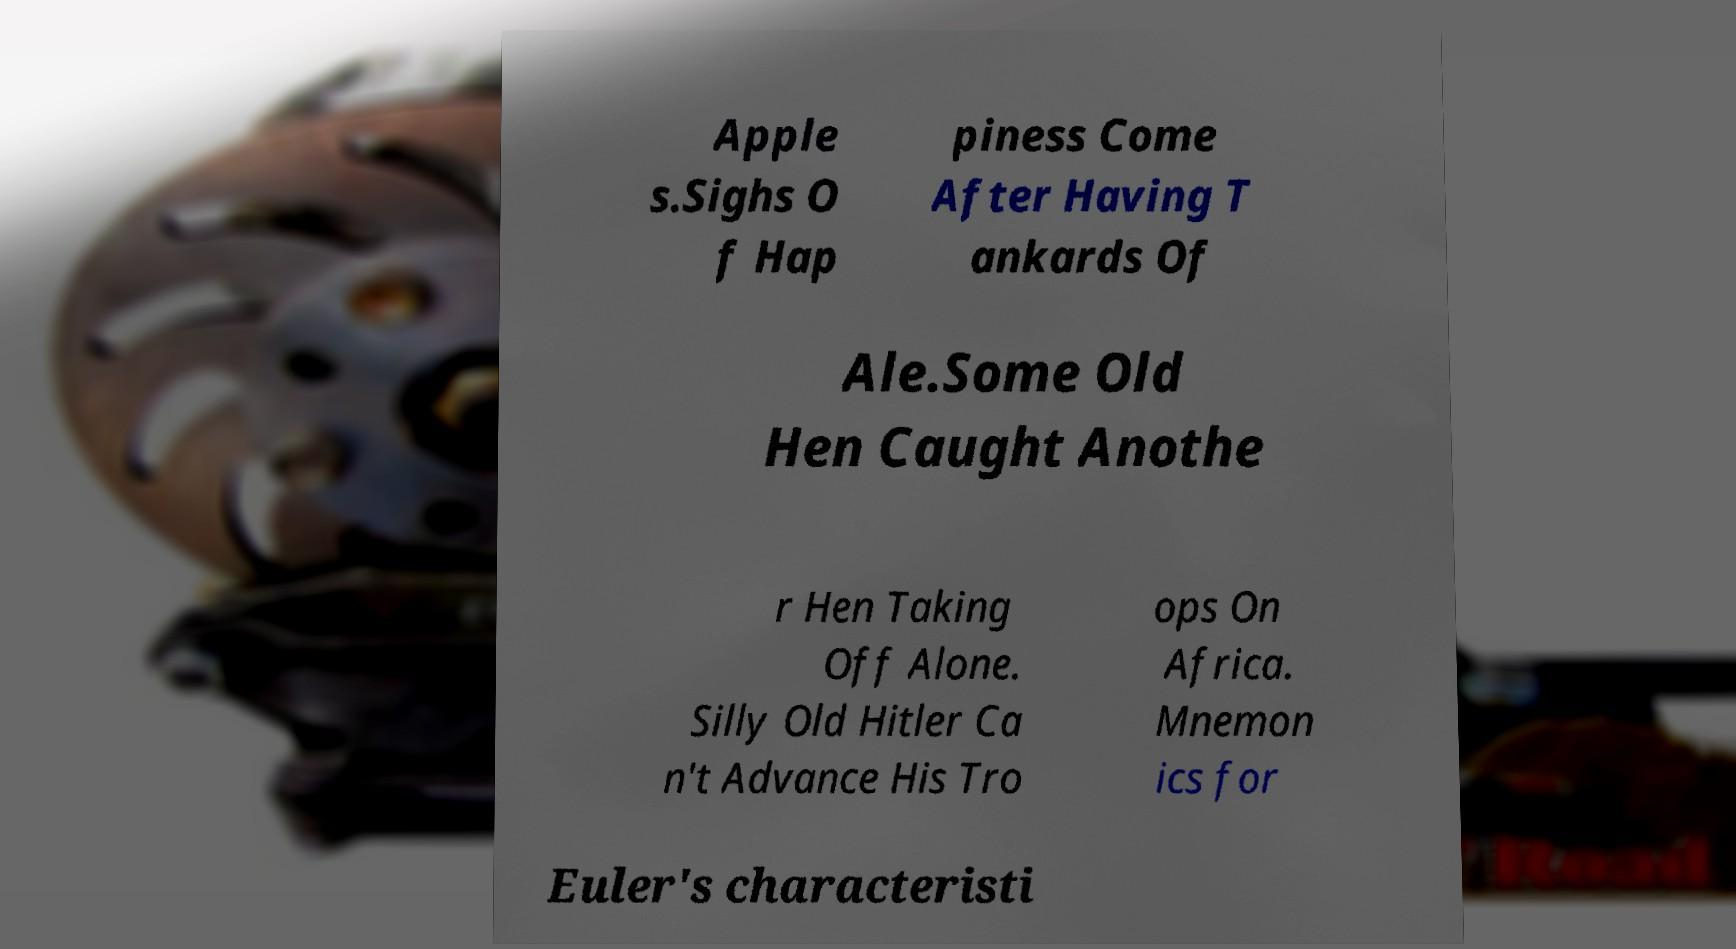I need the written content from this picture converted into text. Can you do that? Apple s.Sighs O f Hap piness Come After Having T ankards Of Ale.Some Old Hen Caught Anothe r Hen Taking Off Alone. Silly Old Hitler Ca n't Advance His Tro ops On Africa. Mnemon ics for Euler's characteristi 